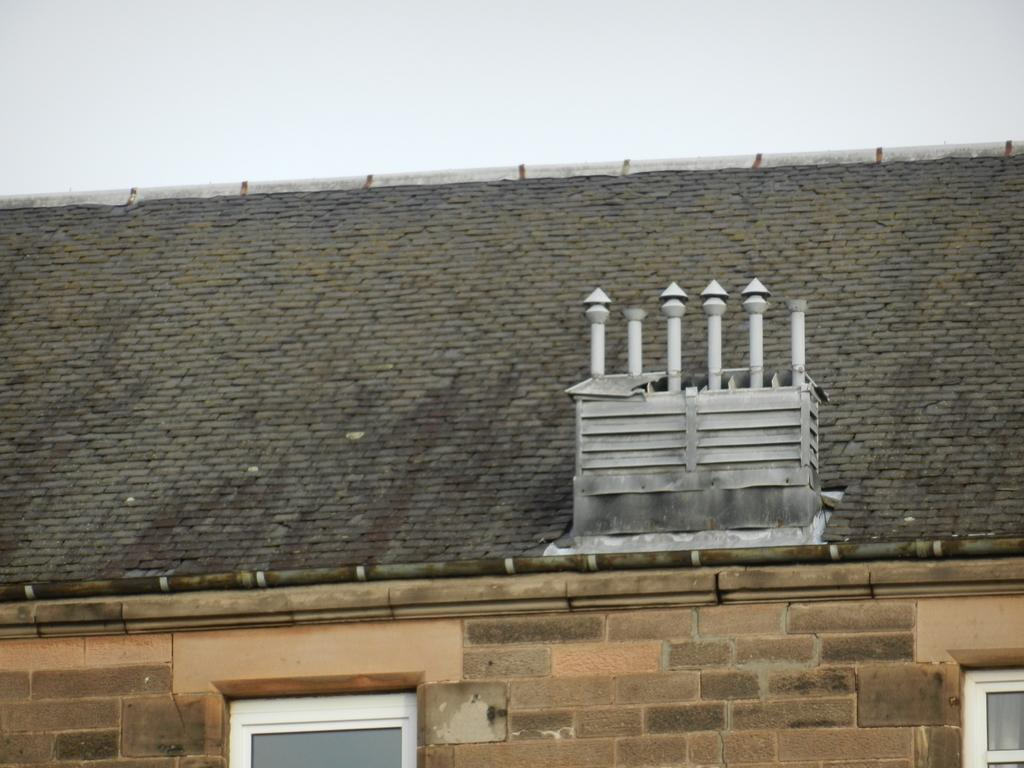What structure is visible at the top of the image? There is a roof in the image. What can be seen at the bottom of the image? There are windows at the bottom of the image. What is visible in the farthest away from the ground in the image? The sky is visible at the top of the image. What type of sock is hanging from the roof in the image? There is no sock present in the image; it only features a roof, windows, and the sky. 